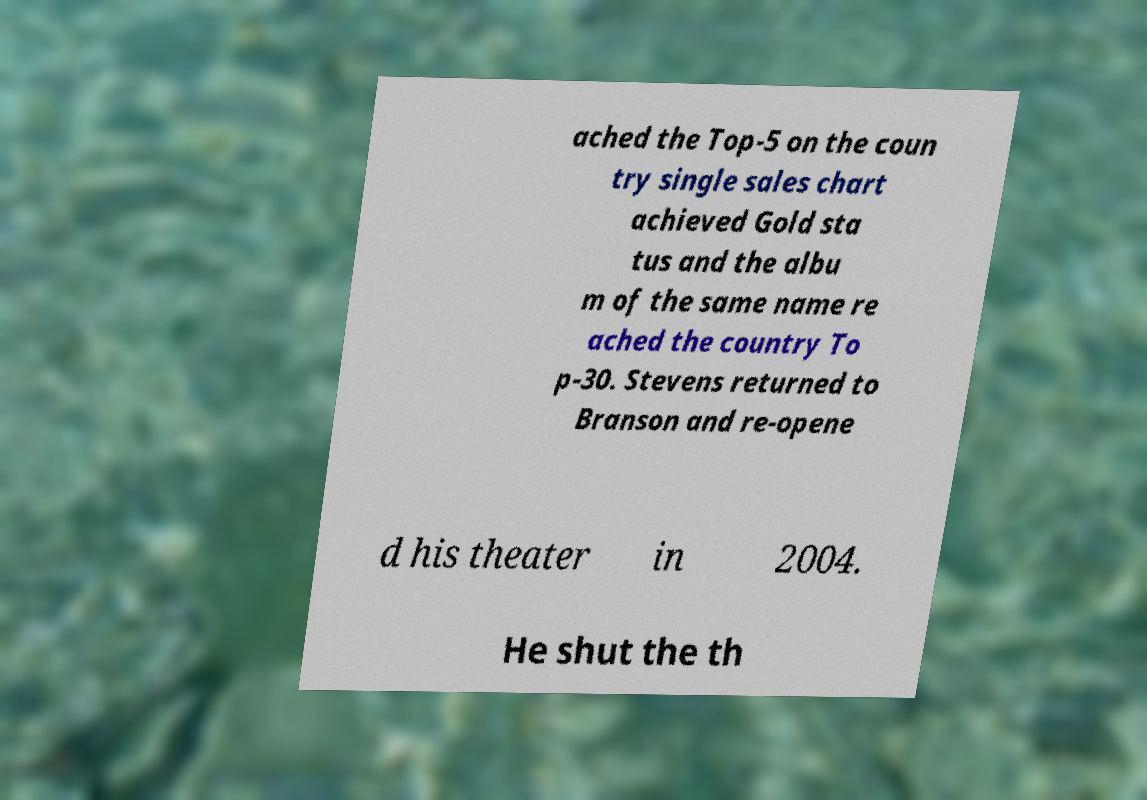What messages or text are displayed in this image? I need them in a readable, typed format. ached the Top-5 on the coun try single sales chart achieved Gold sta tus and the albu m of the same name re ached the country To p-30. Stevens returned to Branson and re-opene d his theater in 2004. He shut the th 